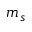Convert formula to latex. <formula><loc_0><loc_0><loc_500><loc_500>m _ { s }</formula> 